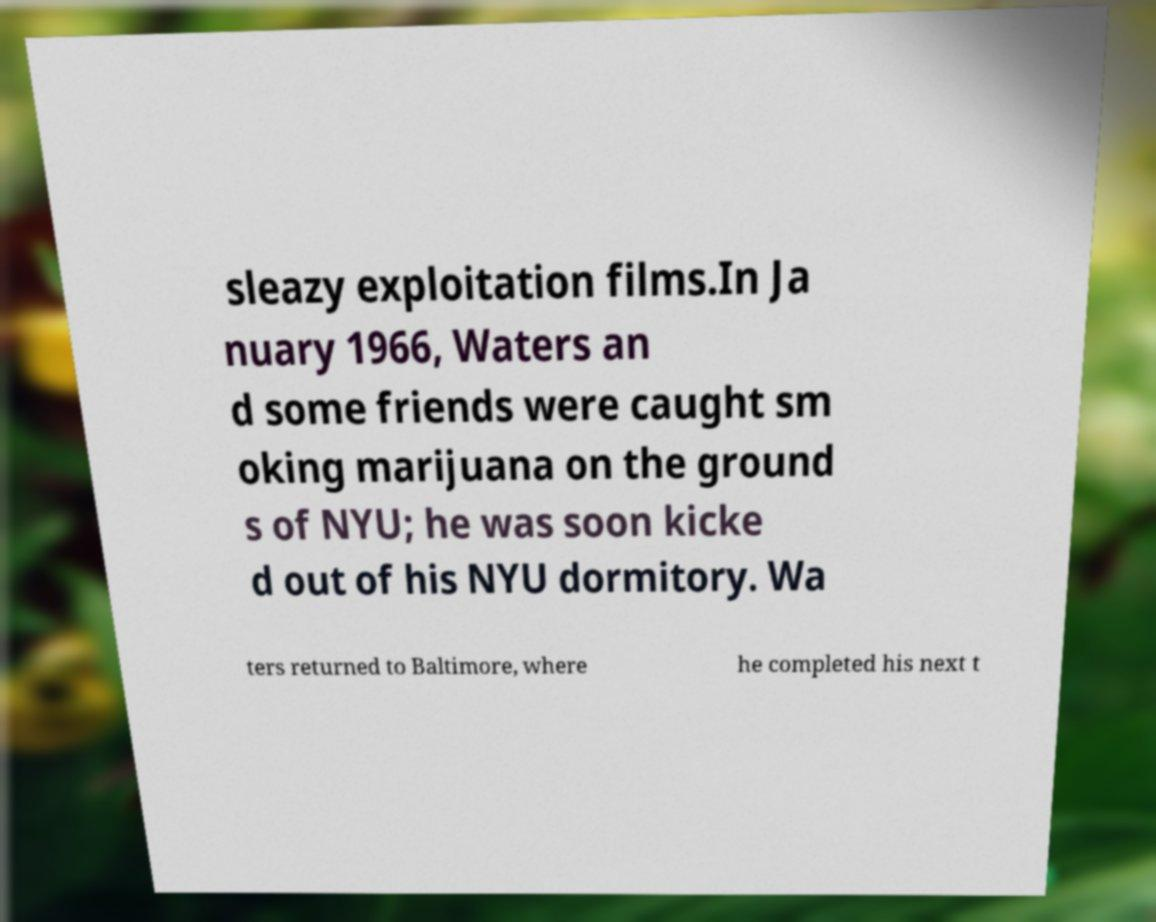Please read and relay the text visible in this image. What does it say? sleazy exploitation films.In Ja nuary 1966, Waters an d some friends were caught sm oking marijuana on the ground s of NYU; he was soon kicke d out of his NYU dormitory. Wa ters returned to Baltimore, where he completed his next t 